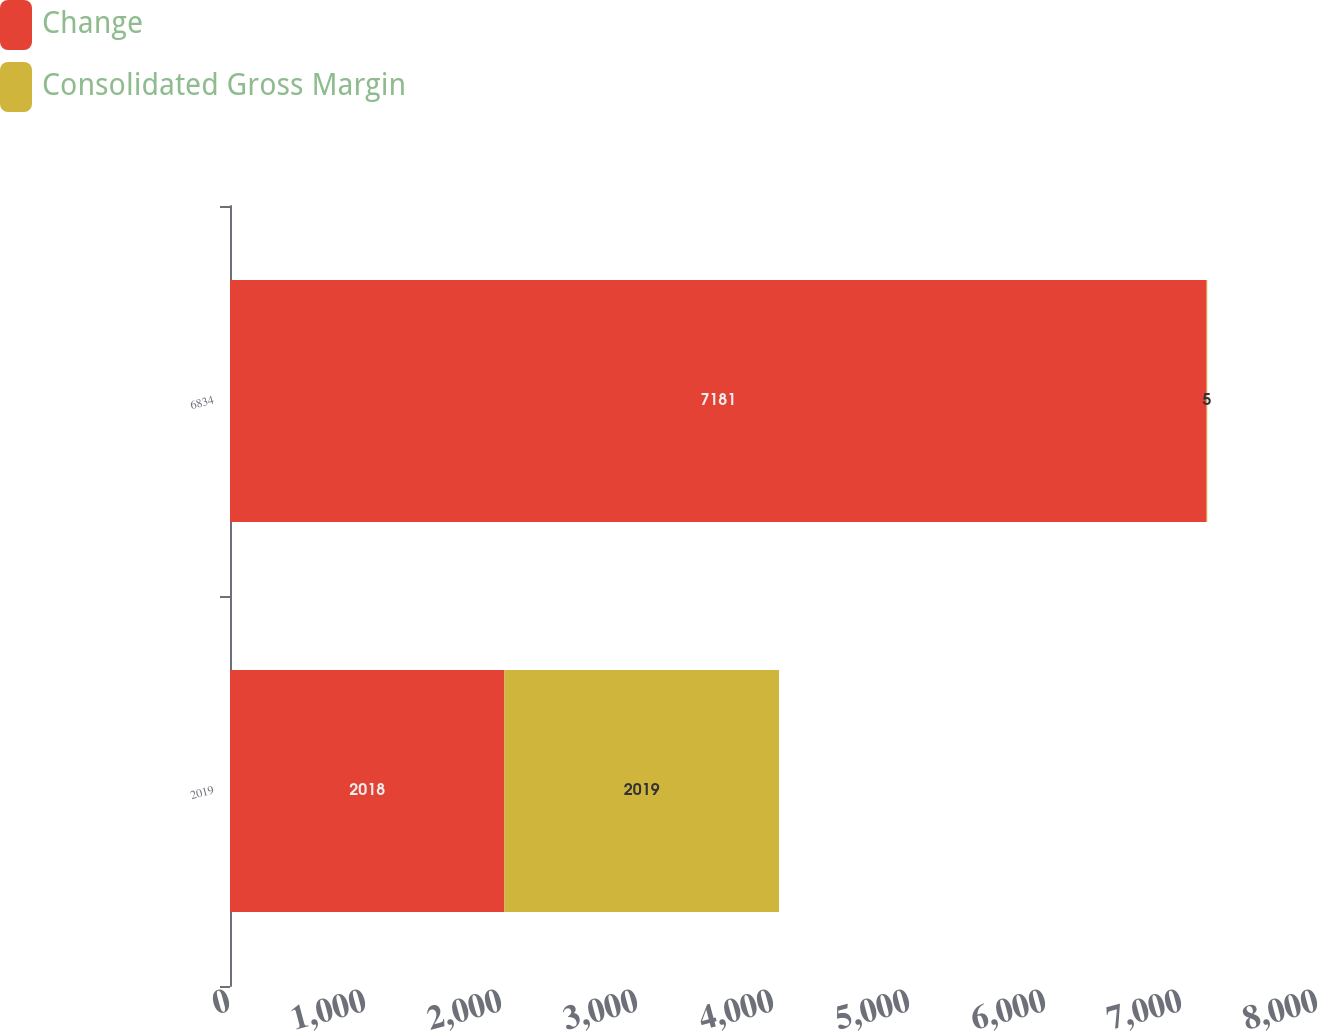<chart> <loc_0><loc_0><loc_500><loc_500><stacked_bar_chart><ecel><fcel>2019<fcel>6834<nl><fcel>Change<fcel>2018<fcel>7181<nl><fcel>Consolidated Gross Margin<fcel>2019<fcel>5<nl></chart> 